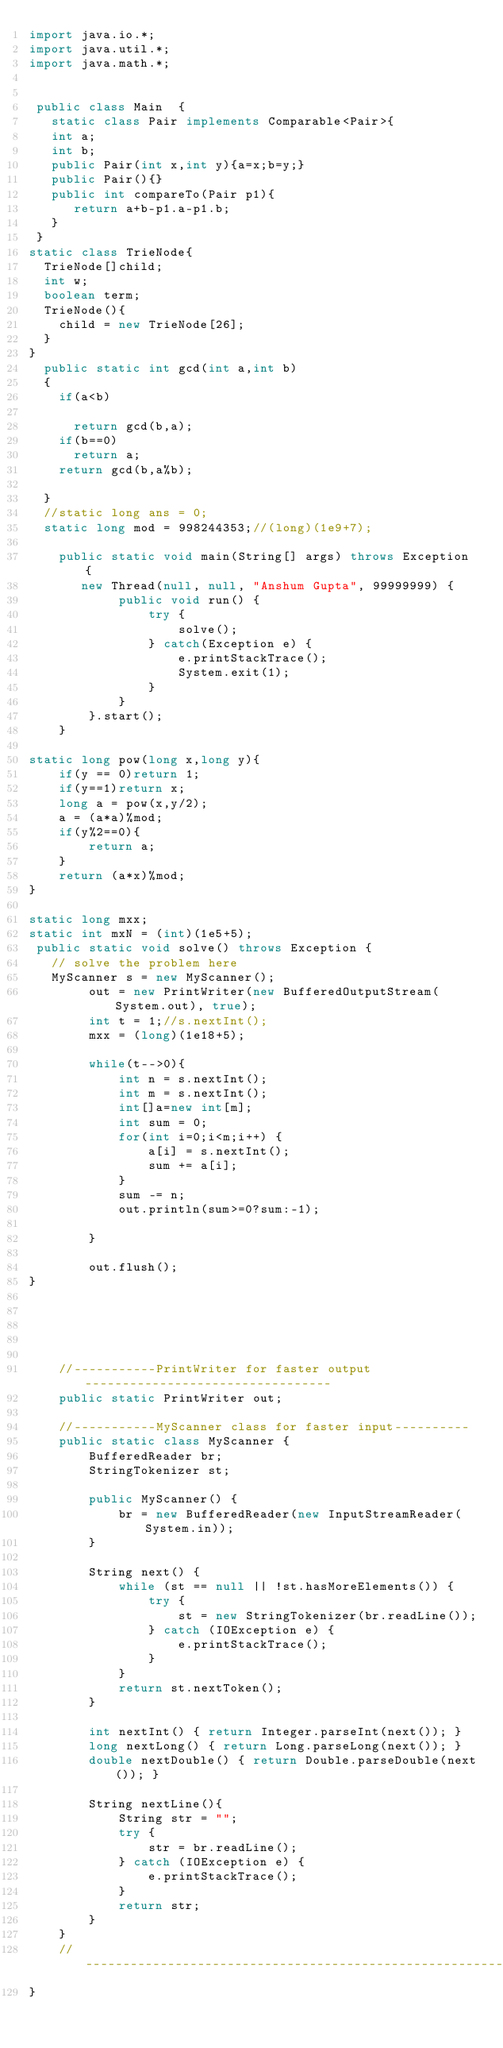Convert code to text. <code><loc_0><loc_0><loc_500><loc_500><_Java_>import java.io.*;
import java.util.*;
import java.math.*;

 
 public class Main	{
   static class Pair implements Comparable<Pair>{
   int a;
   int b;
   public Pair(int x,int y){a=x;b=y;}
   public Pair(){}
   public int compareTo(Pair p1){
      return a+b-p1.a-p1.b;
   }
 }
static class TrieNode{
  TrieNode[]child;
  int w;
  boolean term;
  TrieNode(){
    child = new TrieNode[26];  
  }
}
  public static int gcd(int a,int b)
  {
    if(a<b)

      return gcd(b,a);
    if(b==0)
      return a;
    return gcd(b,a%b);
    
  }
  //static long ans = 0;
  static long mod = 998244353;//(long)(1e9+7);
   
    public static void main(String[] args) throws Exception {
       new Thread(null, null, "Anshum Gupta", 99999999) {
            public void run() {
                try {
                    solve();
                } catch(Exception e) {
                    e.printStackTrace();
                    System.exit(1);
                }
            }
        }.start();
    }

static long pow(long x,long y){
    if(y == 0)return 1;
    if(y==1)return x;
    long a = pow(x,y/2);
    a = (a*a)%mod;
    if(y%2==0){
        return a;
    }
    return (a*x)%mod;
}

static long mxx;
static int mxN = (int)(1e5+5);
 public static void solve() throws Exception {
   // solve the problem here
   MyScanner s = new MyScanner();
        out = new PrintWriter(new BufferedOutputStream(System.out), true);
        int t = 1;//s.nextInt();
        mxx = (long)(1e18+5);
 
        while(t-->0){
        	int n = s.nextInt();
        	int m = s.nextInt();
        	int[]a=new int[m];
        	int sum = 0;
        	for(int i=0;i<m;i++) {
        		a[i] = s.nextInt();
        		sum += a[i];
        	}
        	sum -= n;
        	out.println(sum>=0?sum:-1);
        	
        }
           
        out.flush();
}
 
     
 
 
 
    //-----------PrintWriter for faster output---------------------------------
    public static PrintWriter out;
 
    //-----------MyScanner class for faster input----------
    public static class MyScanner {
        BufferedReader br;
        StringTokenizer st;
 
        public MyScanner() {
            br = new BufferedReader(new InputStreamReader(System.in));
        }
 
        String next() {
            while (st == null || !st.hasMoreElements()) {
                try {
                    st = new StringTokenizer(br.readLine());
                } catch (IOException e) {
                    e.printStackTrace();
                }
            }
            return st.nextToken();
        }
 
        int nextInt() { return Integer.parseInt(next()); }
        long nextLong() { return Long.parseLong(next()); }
        double nextDouble() { return Double.parseDouble(next()); }
         
        String nextLine(){
            String str = "";
            try {
                str = br.readLine();
            } catch (IOException e) {
                e.printStackTrace();
            }
            return str;
        }
    }
    //--------------------------------------------------------
}
</code> 